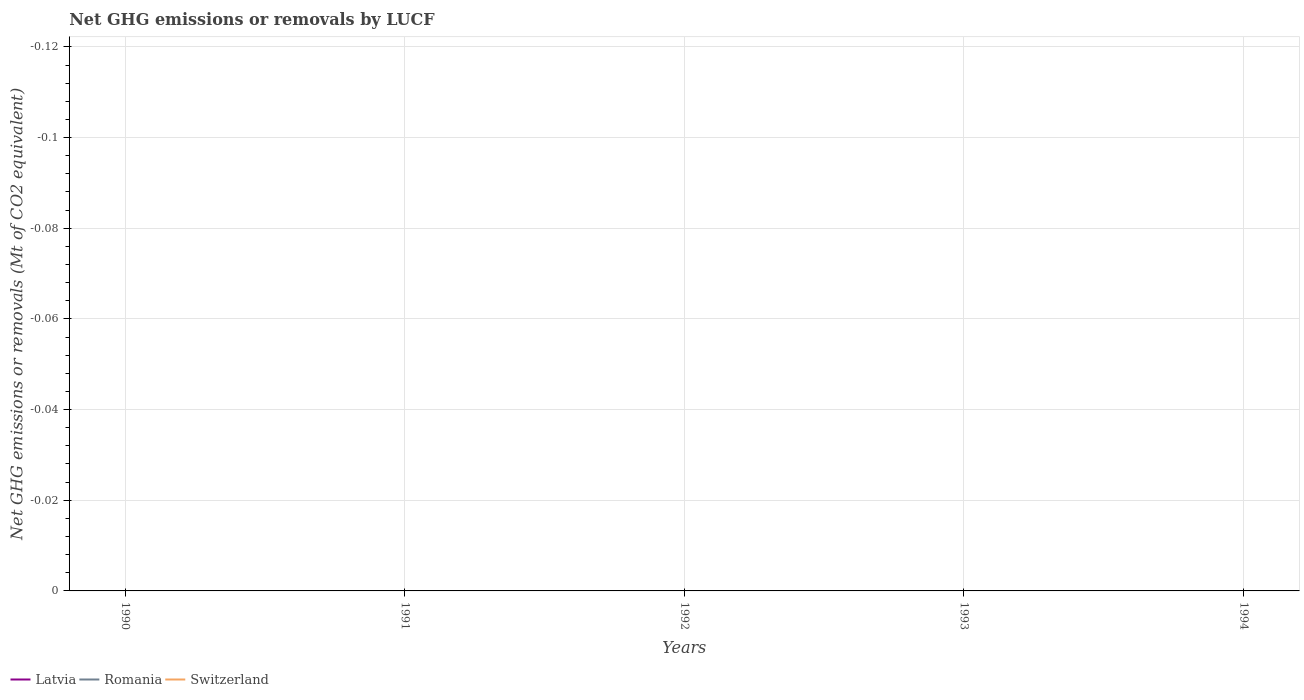Is the number of lines equal to the number of legend labels?
Your answer should be compact. No. Across all years, what is the maximum net GHG emissions or removals by LUCF in Switzerland?
Keep it short and to the point. 0. How many years are there in the graph?
Offer a terse response. 5. What is the difference between two consecutive major ticks on the Y-axis?
Offer a very short reply. 0.02. Are the values on the major ticks of Y-axis written in scientific E-notation?
Your response must be concise. No. Does the graph contain grids?
Your answer should be compact. Yes. What is the title of the graph?
Offer a very short reply. Net GHG emissions or removals by LUCF. Does "Latin America(all income levels)" appear as one of the legend labels in the graph?
Provide a succinct answer. No. What is the label or title of the X-axis?
Your response must be concise. Years. What is the label or title of the Y-axis?
Give a very brief answer. Net GHG emissions or removals (Mt of CO2 equivalent). What is the Net GHG emissions or removals (Mt of CO2 equivalent) of Latvia in 1990?
Your answer should be compact. 0. What is the Net GHG emissions or removals (Mt of CO2 equivalent) in Switzerland in 1990?
Give a very brief answer. 0. What is the Net GHG emissions or removals (Mt of CO2 equivalent) in Latvia in 1991?
Give a very brief answer. 0. What is the Net GHG emissions or removals (Mt of CO2 equivalent) of Romania in 1991?
Ensure brevity in your answer.  0. What is the Net GHG emissions or removals (Mt of CO2 equivalent) of Latvia in 1992?
Give a very brief answer. 0. What is the Net GHG emissions or removals (Mt of CO2 equivalent) of Romania in 1992?
Keep it short and to the point. 0. What is the Net GHG emissions or removals (Mt of CO2 equivalent) of Romania in 1993?
Your answer should be compact. 0. What is the total Net GHG emissions or removals (Mt of CO2 equivalent) in Romania in the graph?
Your answer should be very brief. 0. What is the total Net GHG emissions or removals (Mt of CO2 equivalent) in Switzerland in the graph?
Provide a succinct answer. 0. What is the average Net GHG emissions or removals (Mt of CO2 equivalent) in Romania per year?
Offer a terse response. 0. 